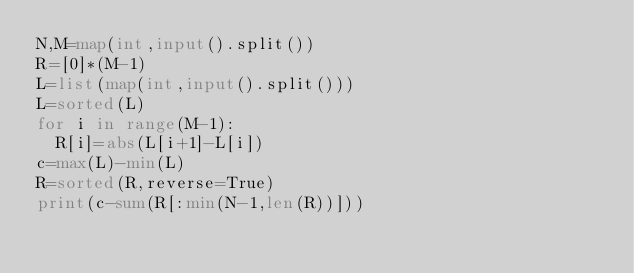Convert code to text. <code><loc_0><loc_0><loc_500><loc_500><_Python_>N,M=map(int,input().split())
R=[0]*(M-1)
L=list(map(int,input().split()))
L=sorted(L)
for i in range(M-1):
  R[i]=abs(L[i+1]-L[i])
c=max(L)-min(L)
R=sorted(R,reverse=True)
print(c-sum(R[:min(N-1,len(R))]))</code> 